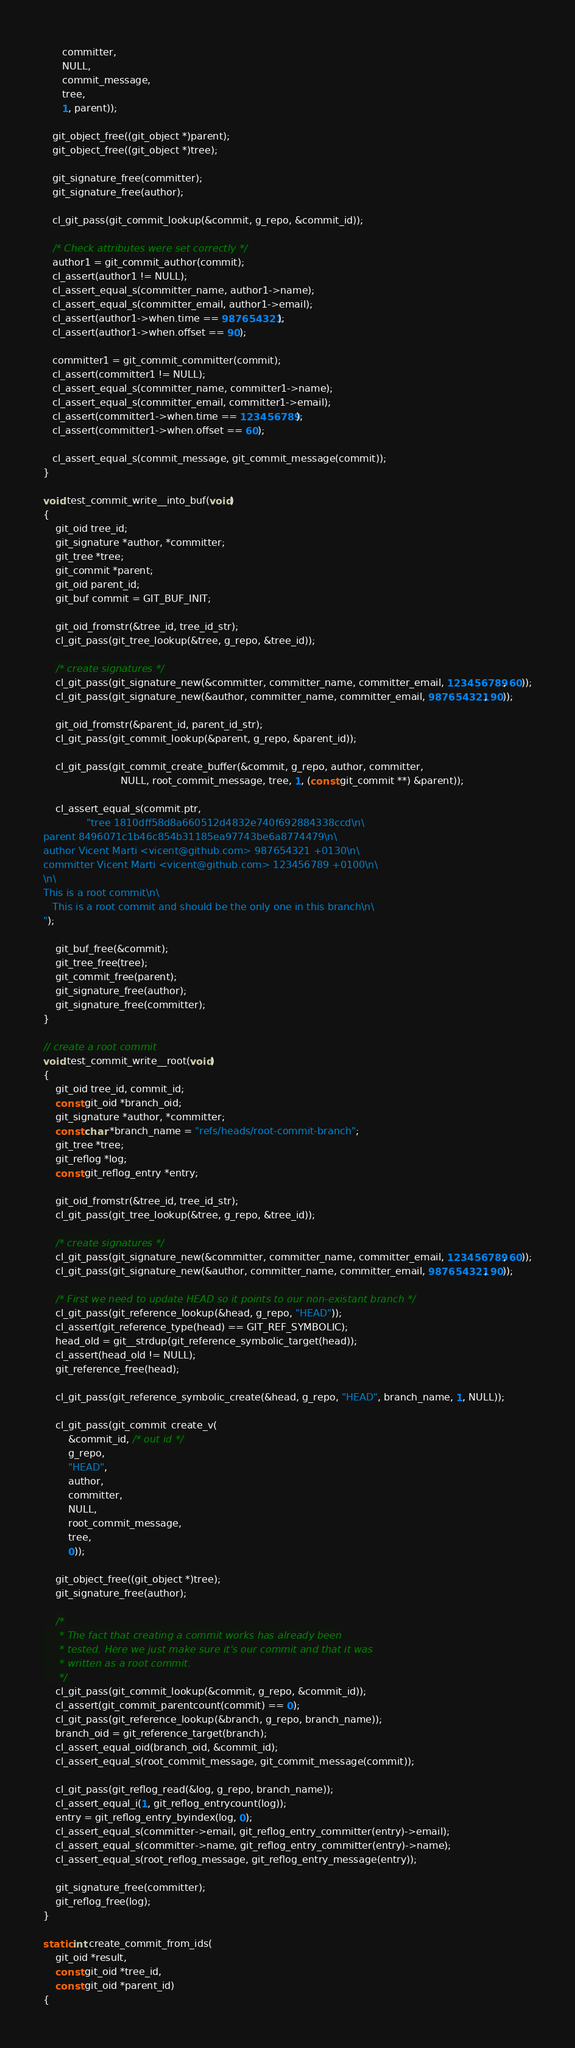<code> <loc_0><loc_0><loc_500><loc_500><_C_>      committer,
      NULL,
      commit_message,
      tree,
      1, parent));

   git_object_free((git_object *)parent);
   git_object_free((git_object *)tree);

   git_signature_free(committer);
   git_signature_free(author);

   cl_git_pass(git_commit_lookup(&commit, g_repo, &commit_id));

   /* Check attributes were set correctly */
   author1 = git_commit_author(commit);
   cl_assert(author1 != NULL);
   cl_assert_equal_s(committer_name, author1->name);
   cl_assert_equal_s(committer_email, author1->email);
   cl_assert(author1->when.time == 987654321);
   cl_assert(author1->when.offset == 90);

   committer1 = git_commit_committer(commit);
   cl_assert(committer1 != NULL);
   cl_assert_equal_s(committer_name, committer1->name);
   cl_assert_equal_s(committer_email, committer1->email);
   cl_assert(committer1->when.time == 123456789);
   cl_assert(committer1->when.offset == 60);

   cl_assert_equal_s(commit_message, git_commit_message(commit));
}

void test_commit_write__into_buf(void)
{
	git_oid tree_id;
	git_signature *author, *committer;
	git_tree *tree;
	git_commit *parent;
	git_oid parent_id;
	git_buf commit = GIT_BUF_INIT;

	git_oid_fromstr(&tree_id, tree_id_str);
	cl_git_pass(git_tree_lookup(&tree, g_repo, &tree_id));

	/* create signatures */
	cl_git_pass(git_signature_new(&committer, committer_name, committer_email, 123456789, 60));
	cl_git_pass(git_signature_new(&author, committer_name, committer_email, 987654321, 90));

	git_oid_fromstr(&parent_id, parent_id_str);
	cl_git_pass(git_commit_lookup(&parent, g_repo, &parent_id));

	cl_git_pass(git_commit_create_buffer(&commit, g_repo, author, committer,
					     NULL, root_commit_message, tree, 1, (const git_commit **) &parent));

	cl_assert_equal_s(commit.ptr,
			  "tree 1810dff58d8a660512d4832e740f692884338ccd\n\
parent 8496071c1b46c854b31185ea97743be6a8774479\n\
author Vicent Marti <vicent@github.com> 987654321 +0130\n\
committer Vicent Marti <vicent@github.com> 123456789 +0100\n\
\n\
This is a root commit\n\
   This is a root commit and should be the only one in this branch\n\
");

	git_buf_free(&commit);
	git_tree_free(tree);
	git_commit_free(parent);
	git_signature_free(author);
	git_signature_free(committer);
}

// create a root commit
void test_commit_write__root(void)
{
	git_oid tree_id, commit_id;
	const git_oid *branch_oid;
	git_signature *author, *committer;
	const char *branch_name = "refs/heads/root-commit-branch";
	git_tree *tree;
	git_reflog *log;
	const git_reflog_entry *entry;

	git_oid_fromstr(&tree_id, tree_id_str);
	cl_git_pass(git_tree_lookup(&tree, g_repo, &tree_id));

	/* create signatures */
	cl_git_pass(git_signature_new(&committer, committer_name, committer_email, 123456789, 60));
	cl_git_pass(git_signature_new(&author, committer_name, committer_email, 987654321, 90));

	/* First we need to update HEAD so it points to our non-existant branch */
	cl_git_pass(git_reference_lookup(&head, g_repo, "HEAD"));
	cl_assert(git_reference_type(head) == GIT_REF_SYMBOLIC);
	head_old = git__strdup(git_reference_symbolic_target(head));
	cl_assert(head_old != NULL);
	git_reference_free(head);

	cl_git_pass(git_reference_symbolic_create(&head, g_repo, "HEAD", branch_name, 1, NULL));

	cl_git_pass(git_commit_create_v(
		&commit_id, /* out id */
		g_repo,
		"HEAD",
		author,
		committer,
		NULL,
		root_commit_message,
		tree,
		0));

	git_object_free((git_object *)tree);
	git_signature_free(author);

	/*
	 * The fact that creating a commit works has already been
	 * tested. Here we just make sure it's our commit and that it was
	 * written as a root commit.
	 */
	cl_git_pass(git_commit_lookup(&commit, g_repo, &commit_id));
	cl_assert(git_commit_parentcount(commit) == 0);
	cl_git_pass(git_reference_lookup(&branch, g_repo, branch_name));
	branch_oid = git_reference_target(branch);
	cl_assert_equal_oid(branch_oid, &commit_id);
	cl_assert_equal_s(root_commit_message, git_commit_message(commit));

	cl_git_pass(git_reflog_read(&log, g_repo, branch_name));
	cl_assert_equal_i(1, git_reflog_entrycount(log));
	entry = git_reflog_entry_byindex(log, 0);
	cl_assert_equal_s(committer->email, git_reflog_entry_committer(entry)->email);
	cl_assert_equal_s(committer->name, git_reflog_entry_committer(entry)->name);
	cl_assert_equal_s(root_reflog_message, git_reflog_entry_message(entry));

	git_signature_free(committer);
	git_reflog_free(log);
}

static int create_commit_from_ids(
	git_oid *result,
	const git_oid *tree_id,
	const git_oid *parent_id)
{</code> 